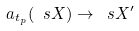<formula> <loc_0><loc_0><loc_500><loc_500>a _ { t _ { p } } ( \ s X ) \rightarrow \ s X ^ { \prime }</formula> 